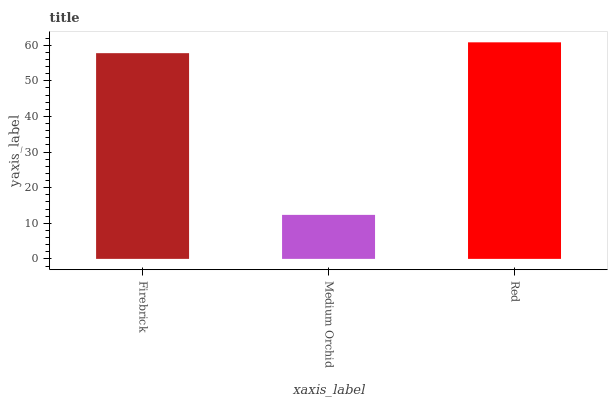Is Medium Orchid the minimum?
Answer yes or no. Yes. Is Red the maximum?
Answer yes or no. Yes. Is Red the minimum?
Answer yes or no. No. Is Medium Orchid the maximum?
Answer yes or no. No. Is Red greater than Medium Orchid?
Answer yes or no. Yes. Is Medium Orchid less than Red?
Answer yes or no. Yes. Is Medium Orchid greater than Red?
Answer yes or no. No. Is Red less than Medium Orchid?
Answer yes or no. No. Is Firebrick the high median?
Answer yes or no. Yes. Is Firebrick the low median?
Answer yes or no. Yes. Is Medium Orchid the high median?
Answer yes or no. No. Is Red the low median?
Answer yes or no. No. 